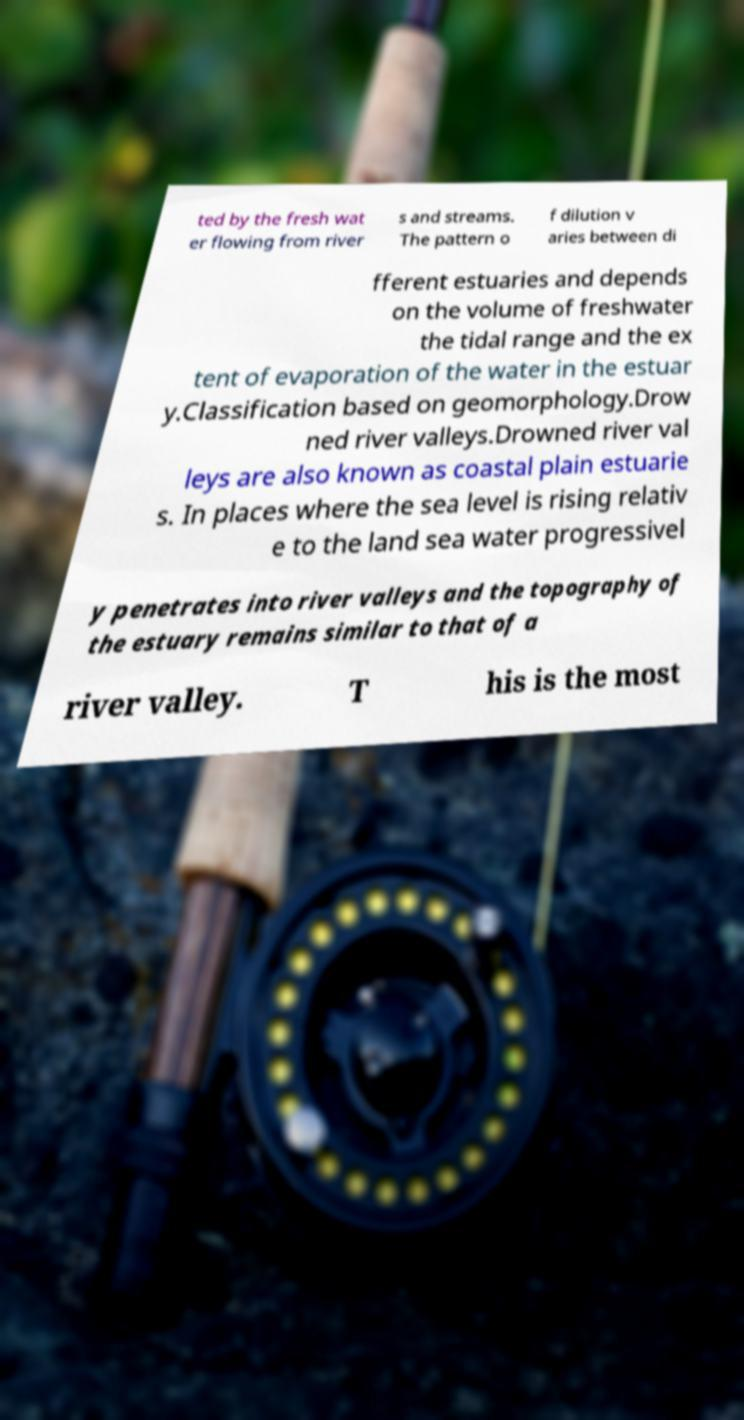Please identify and transcribe the text found in this image. ted by the fresh wat er flowing from river s and streams. The pattern o f dilution v aries between di fferent estuaries and depends on the volume of freshwater the tidal range and the ex tent of evaporation of the water in the estuar y.Classification based on geomorphology.Drow ned river valleys.Drowned river val leys are also known as coastal plain estuarie s. In places where the sea level is rising relativ e to the land sea water progressivel y penetrates into river valleys and the topography of the estuary remains similar to that of a river valley. T his is the most 